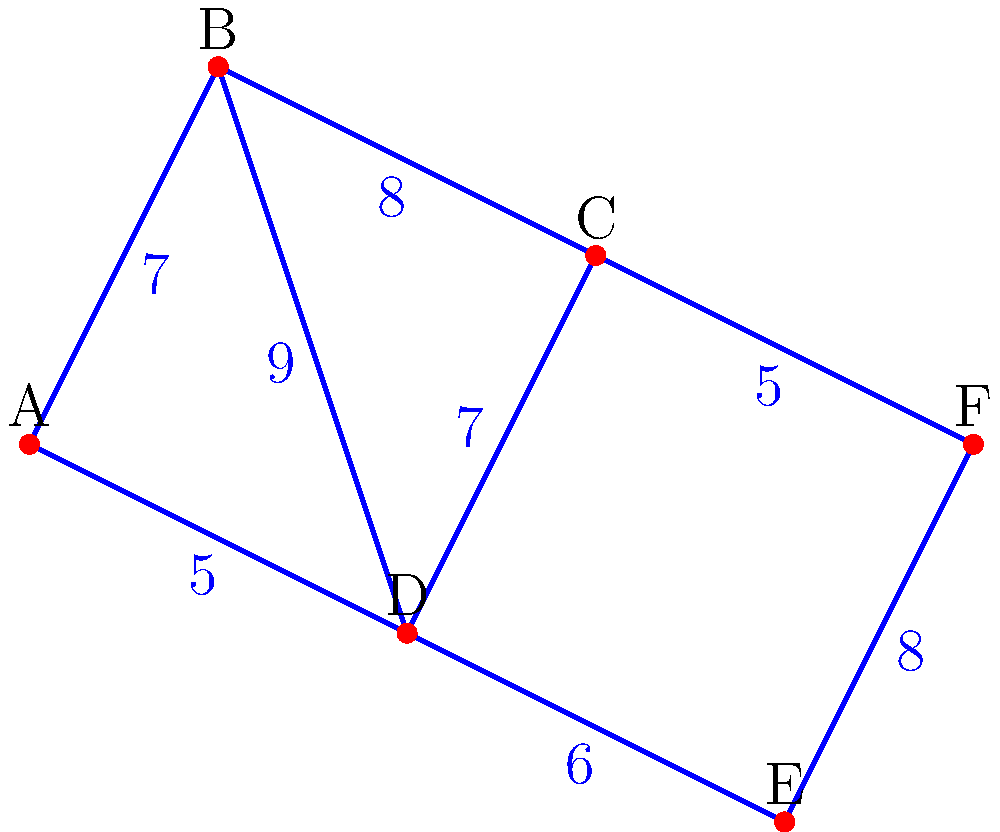You want to create the most efficient network of paths between different areas of your permaculture farm. The graph represents different areas (vertices) and the possible paths between them (edges), with the edge weights indicating the effort required to create each path in terms of labor and resources. What is the total weight of the minimum spanning tree that connects all areas of the farm most efficiently? To find the minimum spanning tree, we'll use Kruskal's algorithm:

1. Sort all edges by weight in ascending order:
   (A,D): 5
   (C,F): 5
   (D,E): 6
   (A,B): 7
   (C,D): 7
   (B,C): 8
   (E,F): 8
   (B,D): 9

2. Start with an empty set of edges and add edges in order, skipping those that would create a cycle:
   - Add (A,D): 5
   - Add (C,F): 5
   - Add (D,E): 6
   - Add (A,B): 7
   - Skip (C,D): would create a cycle
   - Add (B,C): 8

3. We now have a minimum spanning tree with 5 edges (for 6 vertices).

4. Sum the weights of the selected edges:
   5 + 5 + 6 + 7 + 8 = 31

Therefore, the total weight of the minimum spanning tree is 31.
Answer: 31 